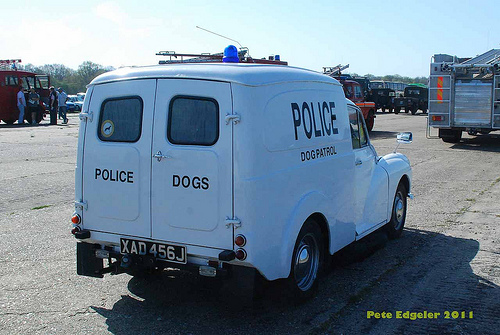<image>
Is there a truck behind the police? No. The truck is not behind the police. From this viewpoint, the truck appears to be positioned elsewhere in the scene. 